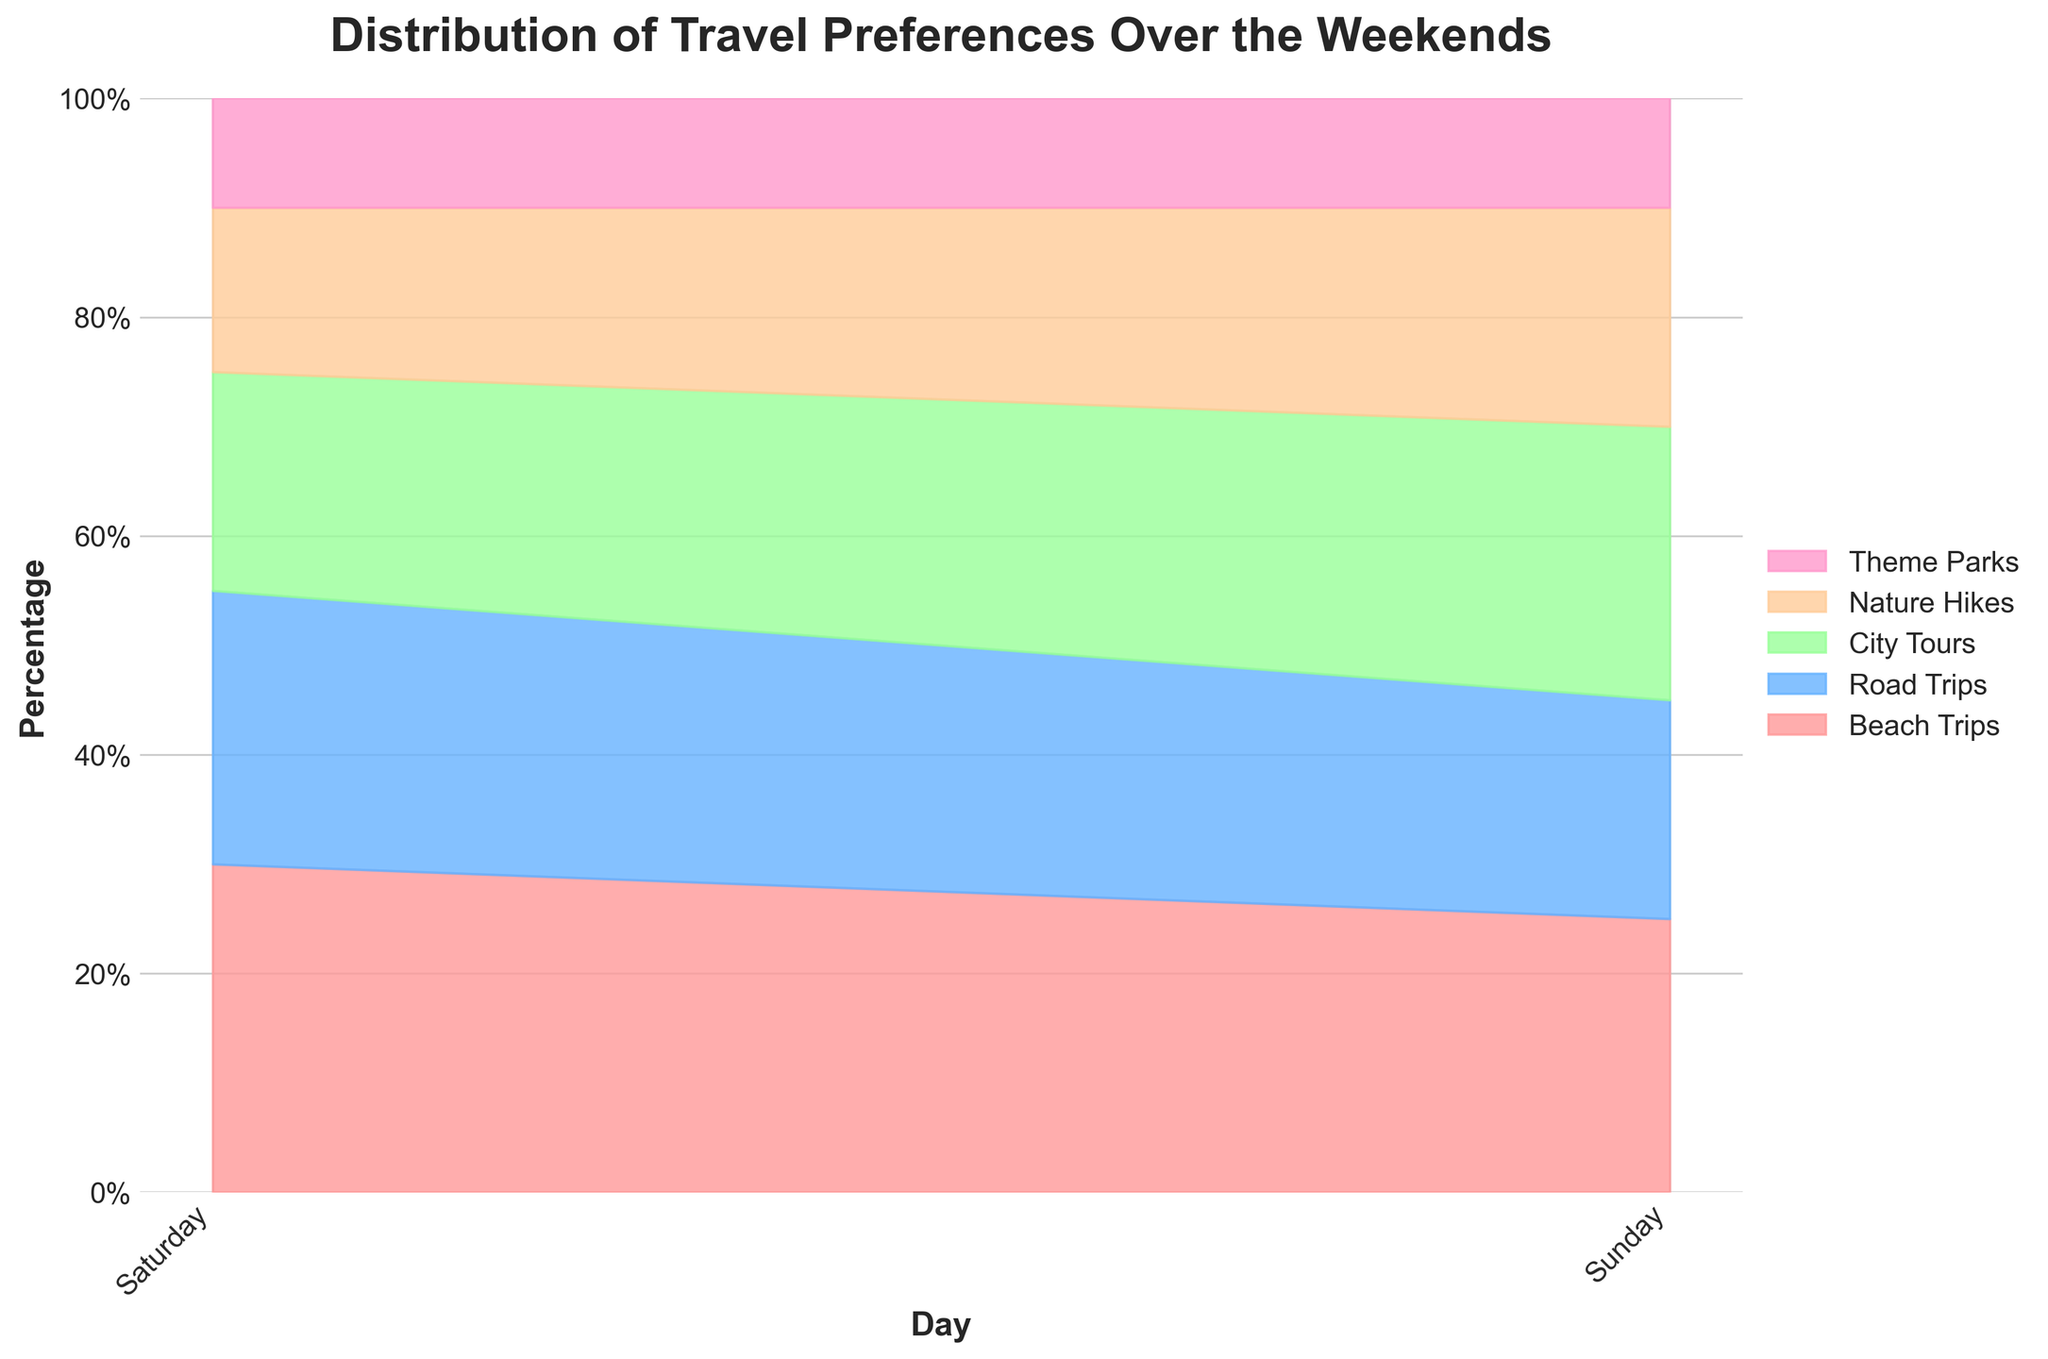What is the title of the figure? The title is written at the top of the figure, often in larger and bold font for prominence. This makes it easy to identify quickly.
Answer: Distribution of Travel Preferences Over the Weekends What are the categories of travel preferences shown in the figure? The categories are listed in the legend, each with a distinct color.
Answer: Beach Trips, Road Trips, City Tours, Nature Hikes, Theme Parks How does the popularity of City Tours on Sunday compare to Saturday? Compare the width (or height in stacked area chart terms) of the "City Tours" section on Saturday and Sunday.
Answer: City Tours are more popular on Sunday than Saturday Which travel preference has the lowest percentage on Saturdays? Look at the bottom segments of all the stacked areas on Saturdays and identify the category with the smallest size consistently.
Answer: Theme Parks On which day is Beach Trips more popular? Compare the size of the area representing Beach Trips between Saturday and Sunday and determine which is larger.
Answer: Saturday How many weekends' data does the chart represent? Count the unique instances of Saturday and Sunday in the x-axis labels.
Answer: 4 weekends What is the combined percentage of Beach Trips and Road Trips on a typical Saturday? Sum the percentages of Beach Trips and Road Trips for any Saturday entry in the dataset.
Answer: 30 + 25 or 32 + 23 or 29 + 24 or 31 + 22 (values vary slightly but around 55%) Which category shows the most consistent percentage over all weekends? Look at the areas for each category and identify which one has the most uniform size across all days.
Answer: Theme Parks What is the trend for Nature Hikes from Saturday to Sunday? Compare the size of the areas representing Nature Hikes on Saturday with those on Sunday and note any increase or decrease.
Answer: Trend shows slight increase on Sunday 